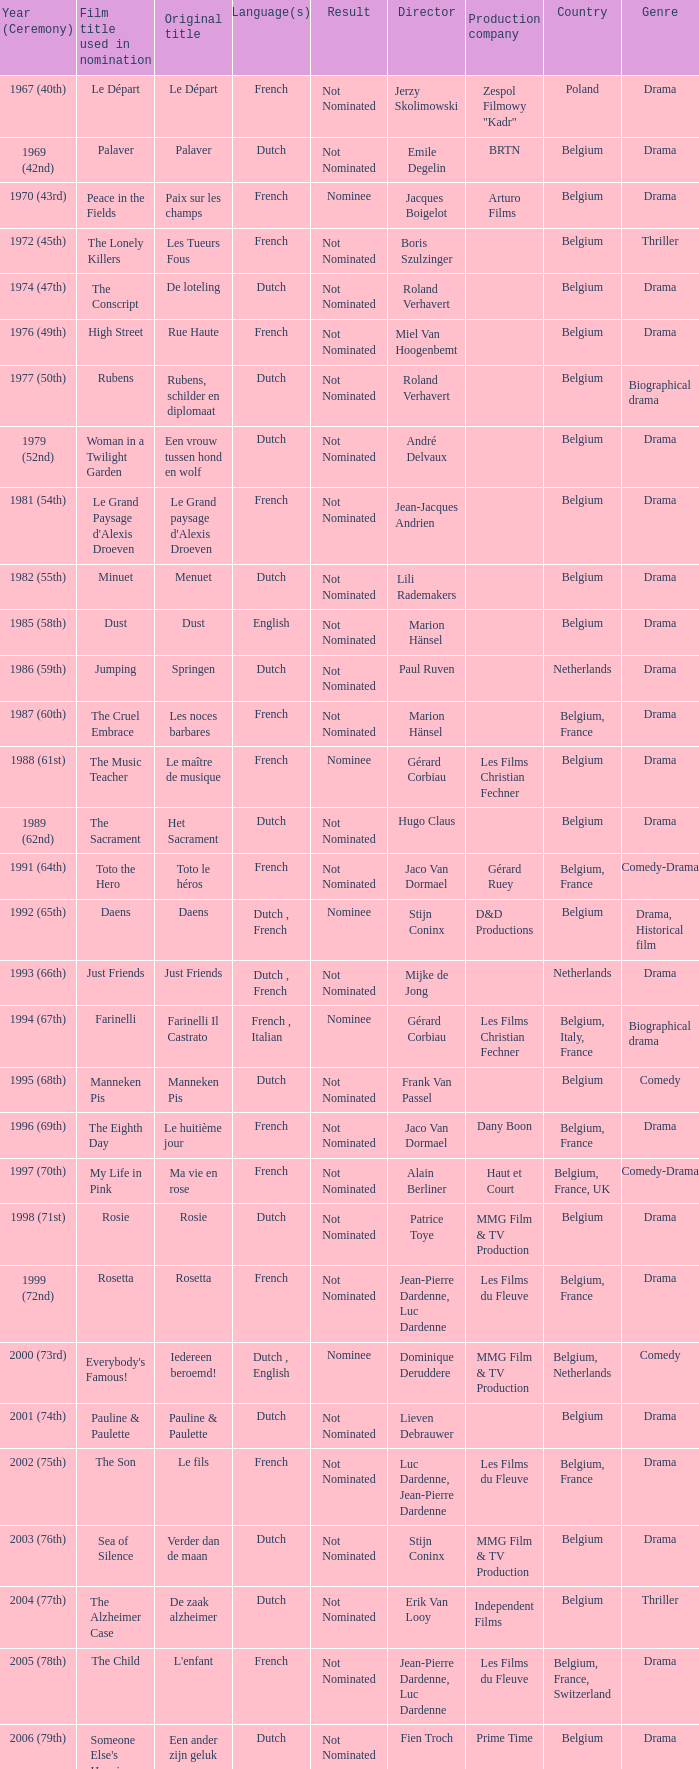What was the title used for Rosie, the film nominated for the dutch language? Rosie. 